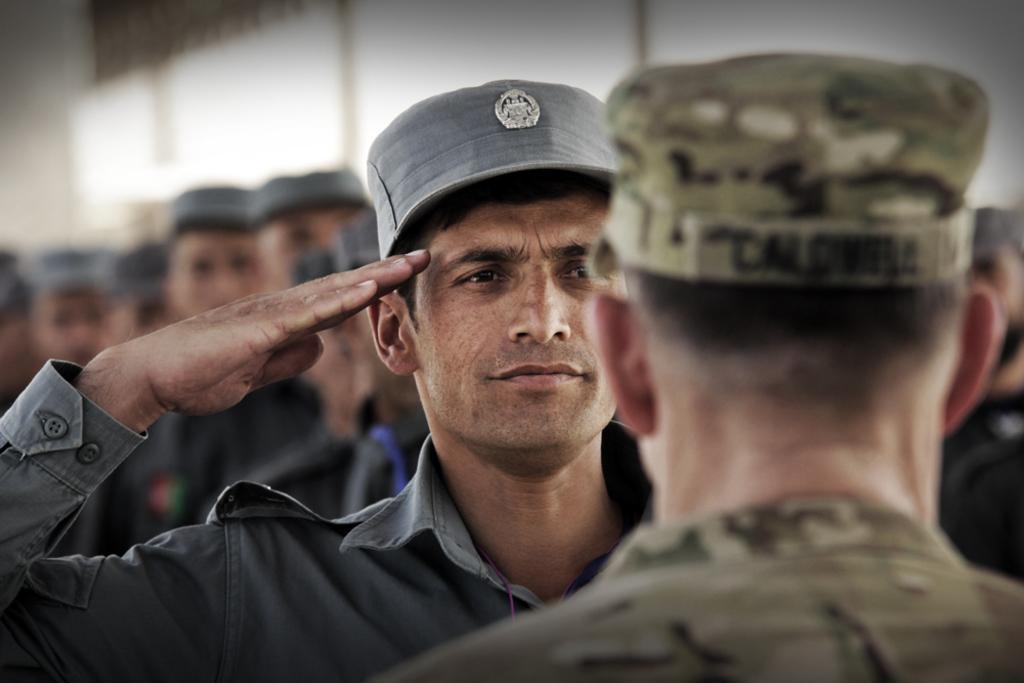Please provide a concise description of this image. In this picture we can see a man wearing a cap and saluting. On the right side of the picture we can see a man wearing a cap. Background portion of the picture is blurred and we can see people. 